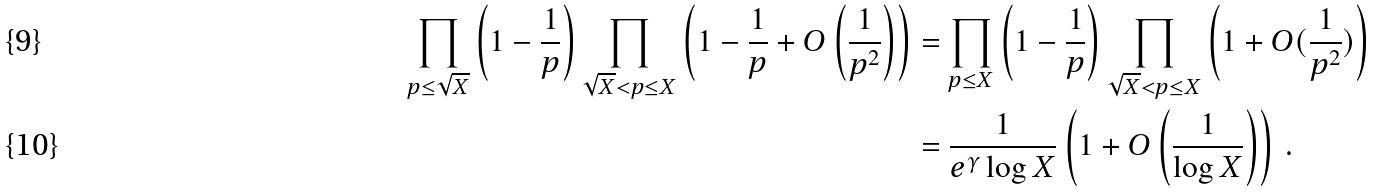<formula> <loc_0><loc_0><loc_500><loc_500>\prod _ { p \leq \sqrt { X } } \left ( 1 - \frac { 1 } { p } \right ) \prod _ { \sqrt { X } < p \leq X } \left ( 1 - \frac { 1 } { p } + O \left ( \frac { 1 } { p ^ { 2 } } \right ) \right ) & = \prod _ { p \leq X } \left ( 1 - \frac { 1 } { p } \right ) \prod _ { \sqrt { X } < p \leq X } \left ( 1 + O ( \frac { 1 } { p ^ { 2 } } ) \right ) \\ & = \frac { 1 } { e ^ { \gamma } \log X } \left ( 1 + O \left ( \frac { 1 } { \log X } \right ) \right ) \, .</formula> 